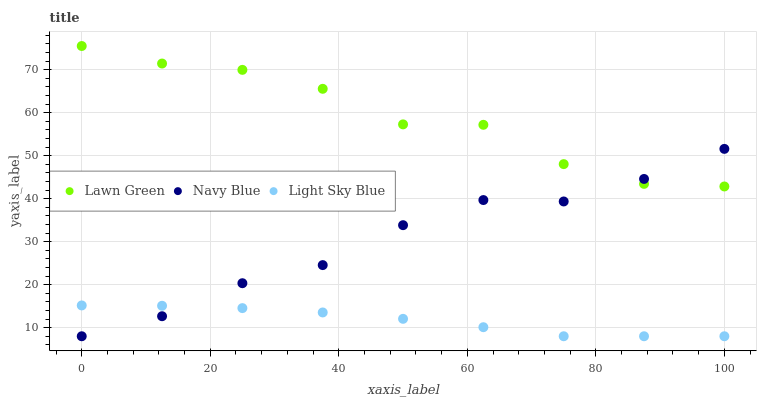Does Light Sky Blue have the minimum area under the curve?
Answer yes or no. Yes. Does Lawn Green have the maximum area under the curve?
Answer yes or no. Yes. Does Navy Blue have the minimum area under the curve?
Answer yes or no. No. Does Navy Blue have the maximum area under the curve?
Answer yes or no. No. Is Light Sky Blue the smoothest?
Answer yes or no. Yes. Is Lawn Green the roughest?
Answer yes or no. Yes. Is Navy Blue the smoothest?
Answer yes or no. No. Is Navy Blue the roughest?
Answer yes or no. No. Does Light Sky Blue have the lowest value?
Answer yes or no. Yes. Does Lawn Green have the highest value?
Answer yes or no. Yes. Does Navy Blue have the highest value?
Answer yes or no. No. Is Light Sky Blue less than Lawn Green?
Answer yes or no. Yes. Is Lawn Green greater than Light Sky Blue?
Answer yes or no. Yes. Does Navy Blue intersect Lawn Green?
Answer yes or no. Yes. Is Navy Blue less than Lawn Green?
Answer yes or no. No. Is Navy Blue greater than Lawn Green?
Answer yes or no. No. Does Light Sky Blue intersect Lawn Green?
Answer yes or no. No. 